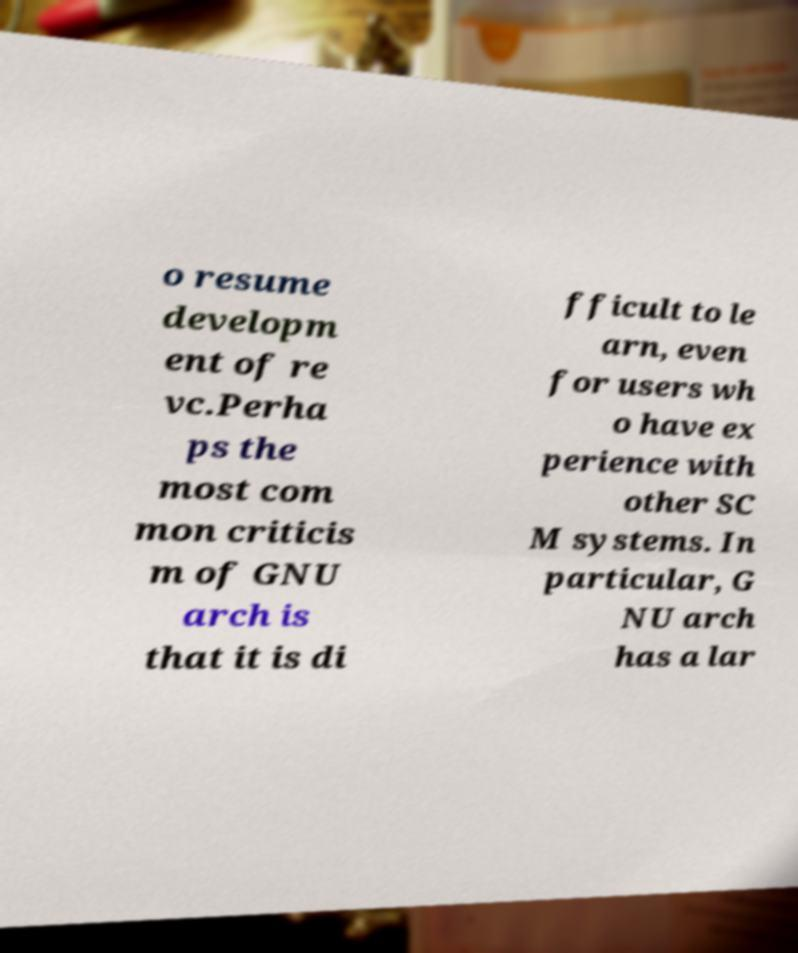Can you read and provide the text displayed in the image?This photo seems to have some interesting text. Can you extract and type it out for me? o resume developm ent of re vc.Perha ps the most com mon criticis m of GNU arch is that it is di fficult to le arn, even for users wh o have ex perience with other SC M systems. In particular, G NU arch has a lar 